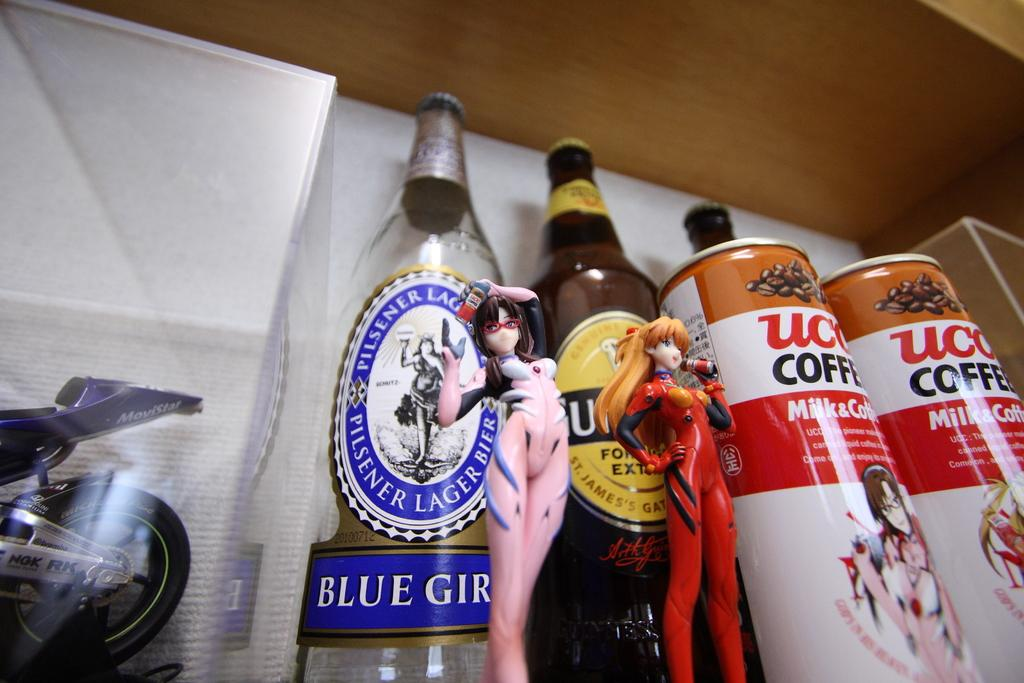What type of toy is located on the left side of the image? There is a bike toy on the left side of the image. What can be seen on the right side of the image? There are tins on the right side of the image. How many bottles are visible in the middle of the image? There are two bottles in the middle of the image. What is placed before the bottles? There are two toys placed before the bottles. What type of meat is being prepared on the toy bike in the image? There is no meat or cooking activity present in the image; it features a bike toy, tins, bottles, and other toys. What is the zebra doing with the whip in the image? There is no zebra or whip present in the image. 